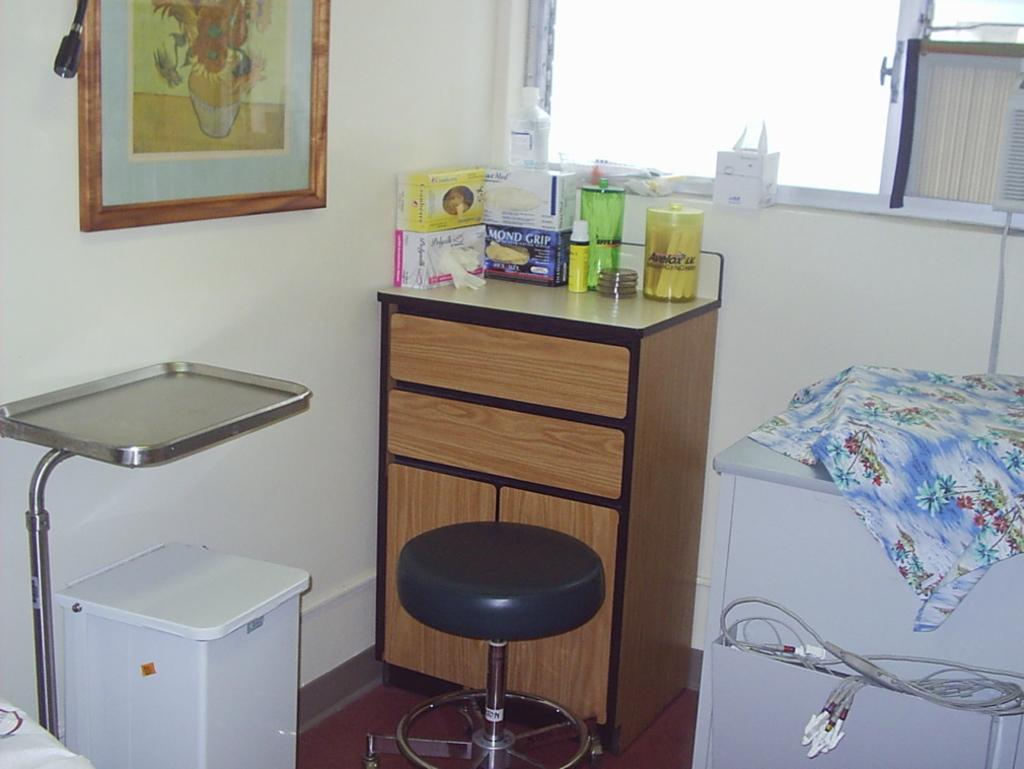What type of furniture is present in the image? There is a chair in the image. What can be seen on the wall in the image? There is a frame on the wall in the image. What is on the shelf in the image? There is a shelf in the image with objects placed on it. What is the box with wires used for? The box with wires is not explicitly described in the facts, but it may be related to electronics or wiring. What type of material is visible in the image? There is cloth visible in the image. What type of war is depicted in the frame on the wall? There is no war depicted in the frame on the wall; it is not mentioned in the facts. Can you see a monkey interacting with the cloth in the image? There is no monkey present in the image. 